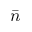<formula> <loc_0><loc_0><loc_500><loc_500>\bar { n }</formula> 